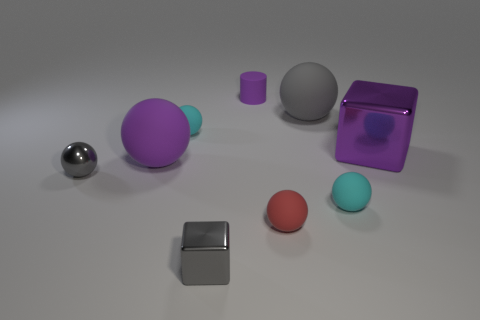Is there any other thing that has the same shape as the tiny purple object?
Provide a short and direct response. No. Are there fewer small gray metallic balls on the right side of the tiny gray metallic block than shiny cubes on the right side of the gray matte ball?
Your response must be concise. Yes. What number of small spheres are the same color as the small block?
Ensure brevity in your answer.  1. There is a tiny sphere that is the same color as the small metal cube; what is its material?
Provide a succinct answer. Metal. What number of small objects are behind the small red thing and to the left of the tiny rubber cylinder?
Make the answer very short. 2. There is a cyan sphere on the left side of the purple rubber thing that is behind the large purple cube; what is it made of?
Offer a very short reply. Rubber. Is there a big purple object that has the same material as the red ball?
Your answer should be very brief. Yes. What material is the block that is the same size as the red sphere?
Provide a succinct answer. Metal. There is a cube that is to the left of the big rubber sphere right of the tiny gray thing to the right of the large purple rubber sphere; what is its size?
Ensure brevity in your answer.  Small. There is a purple rubber thing that is behind the gray rubber sphere; is there a small cyan thing that is to the right of it?
Make the answer very short. Yes. 